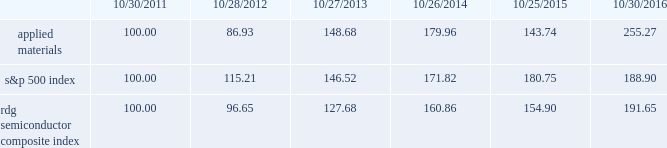Performance graph the performance graph below shows the five-year cumulative total stockholder return on applied common stock during the period from october 30 , 2011 through october 30 , 2016 .
This is compared with the cumulative total return of the standard & poor 2019s 500 stock index and the rdg semiconductor composite index over the same period .
The comparison assumes $ 100 was invested on october 30 , 2011 in applied common stock and in each of the foregoing indices and assumes reinvestment of dividends , if any .
Dollar amounts in the graph are rounded to the nearest whole dollar .
The performance shown in the graph represents past performance and should not be considered an indication of future performance .
Comparison of 5 year cumulative total return* among applied materials , inc. , the s&p 500 index and the rdg semiconductor composite index *assumes $ 100 invested on 10/30/11 in stock or 10/31/11 in index , including reinvestment of dividends .
Indexes calculated on month-end basis .
Copyright a9 2016 standard & poor 2019s , a division of s&p global .
All rights reserved. .
Dividends during each of fiscal 2016 , 2015 , and 2014 , applied 2019s board of directors declared four quarterly cash dividends in the amount of $ 0.10 per share .
Applied currently anticipates that cash dividends will continue to be paid on a quarterly basis , although the declaration of any future cash dividend is at the discretion of the board of directors and will depend on applied 2019s financial condition , results of operations , capital requirements , business conditions and other factors , as well as a determination by the board of directors that cash dividends are in the best interests of applied 2019s stockholders .
10/30/11 10/28/12 10/27/13 10/26/14 10/25/15 10/30/16 applied materials , inc .
S&p 500 rdg semiconductor composite .
What is the total return if 1000000 is invested in applied materials in 2011 and sold in 2012? 
Computations: ((1000000 / 100) * (86.93 - 100))
Answer: -130700.0. 